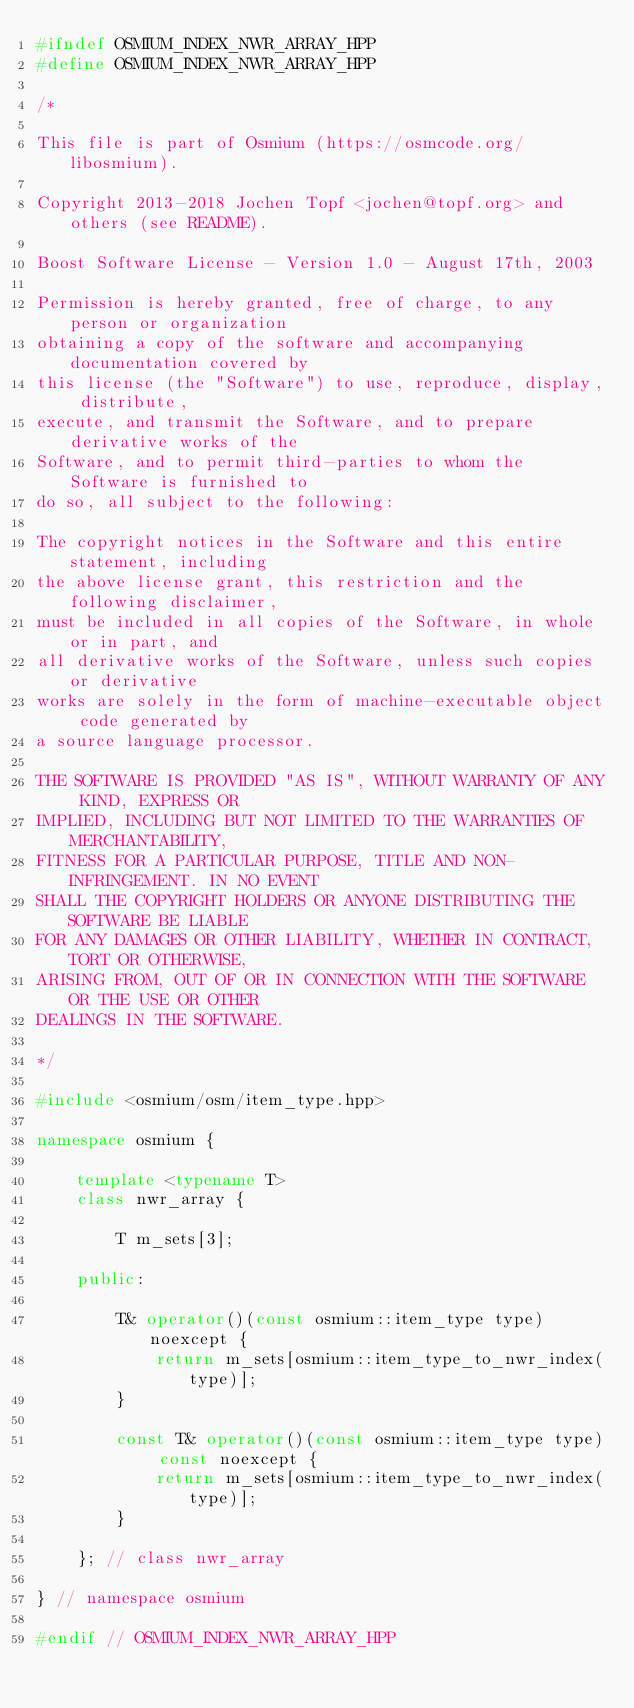<code> <loc_0><loc_0><loc_500><loc_500><_C++_>#ifndef OSMIUM_INDEX_NWR_ARRAY_HPP
#define OSMIUM_INDEX_NWR_ARRAY_HPP

/*

This file is part of Osmium (https://osmcode.org/libosmium).

Copyright 2013-2018 Jochen Topf <jochen@topf.org> and others (see README).

Boost Software License - Version 1.0 - August 17th, 2003

Permission is hereby granted, free of charge, to any person or organization
obtaining a copy of the software and accompanying documentation covered by
this license (the "Software") to use, reproduce, display, distribute,
execute, and transmit the Software, and to prepare derivative works of the
Software, and to permit third-parties to whom the Software is furnished to
do so, all subject to the following:

The copyright notices in the Software and this entire statement, including
the above license grant, this restriction and the following disclaimer,
must be included in all copies of the Software, in whole or in part, and
all derivative works of the Software, unless such copies or derivative
works are solely in the form of machine-executable object code generated by
a source language processor.

THE SOFTWARE IS PROVIDED "AS IS", WITHOUT WARRANTY OF ANY KIND, EXPRESS OR
IMPLIED, INCLUDING BUT NOT LIMITED TO THE WARRANTIES OF MERCHANTABILITY,
FITNESS FOR A PARTICULAR PURPOSE, TITLE AND NON-INFRINGEMENT. IN NO EVENT
SHALL THE COPYRIGHT HOLDERS OR ANYONE DISTRIBUTING THE SOFTWARE BE LIABLE
FOR ANY DAMAGES OR OTHER LIABILITY, WHETHER IN CONTRACT, TORT OR OTHERWISE,
ARISING FROM, OUT OF OR IN CONNECTION WITH THE SOFTWARE OR THE USE OR OTHER
DEALINGS IN THE SOFTWARE.

*/

#include <osmium/osm/item_type.hpp>

namespace osmium {

    template <typename T>
    class nwr_array {

        T m_sets[3];

    public:

        T& operator()(const osmium::item_type type) noexcept {
            return m_sets[osmium::item_type_to_nwr_index(type)];
        }

        const T& operator()(const osmium::item_type type) const noexcept {
            return m_sets[osmium::item_type_to_nwr_index(type)];
        }

    }; // class nwr_array

} // namespace osmium

#endif // OSMIUM_INDEX_NWR_ARRAY_HPP
</code> 